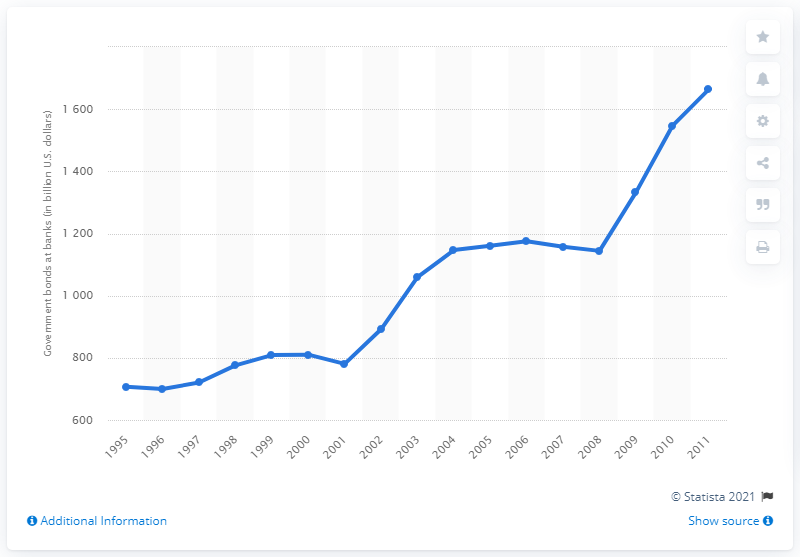List a handful of essential elements in this visual. In 2010, the value of US government securities held by commercial banks was 1546.1... 